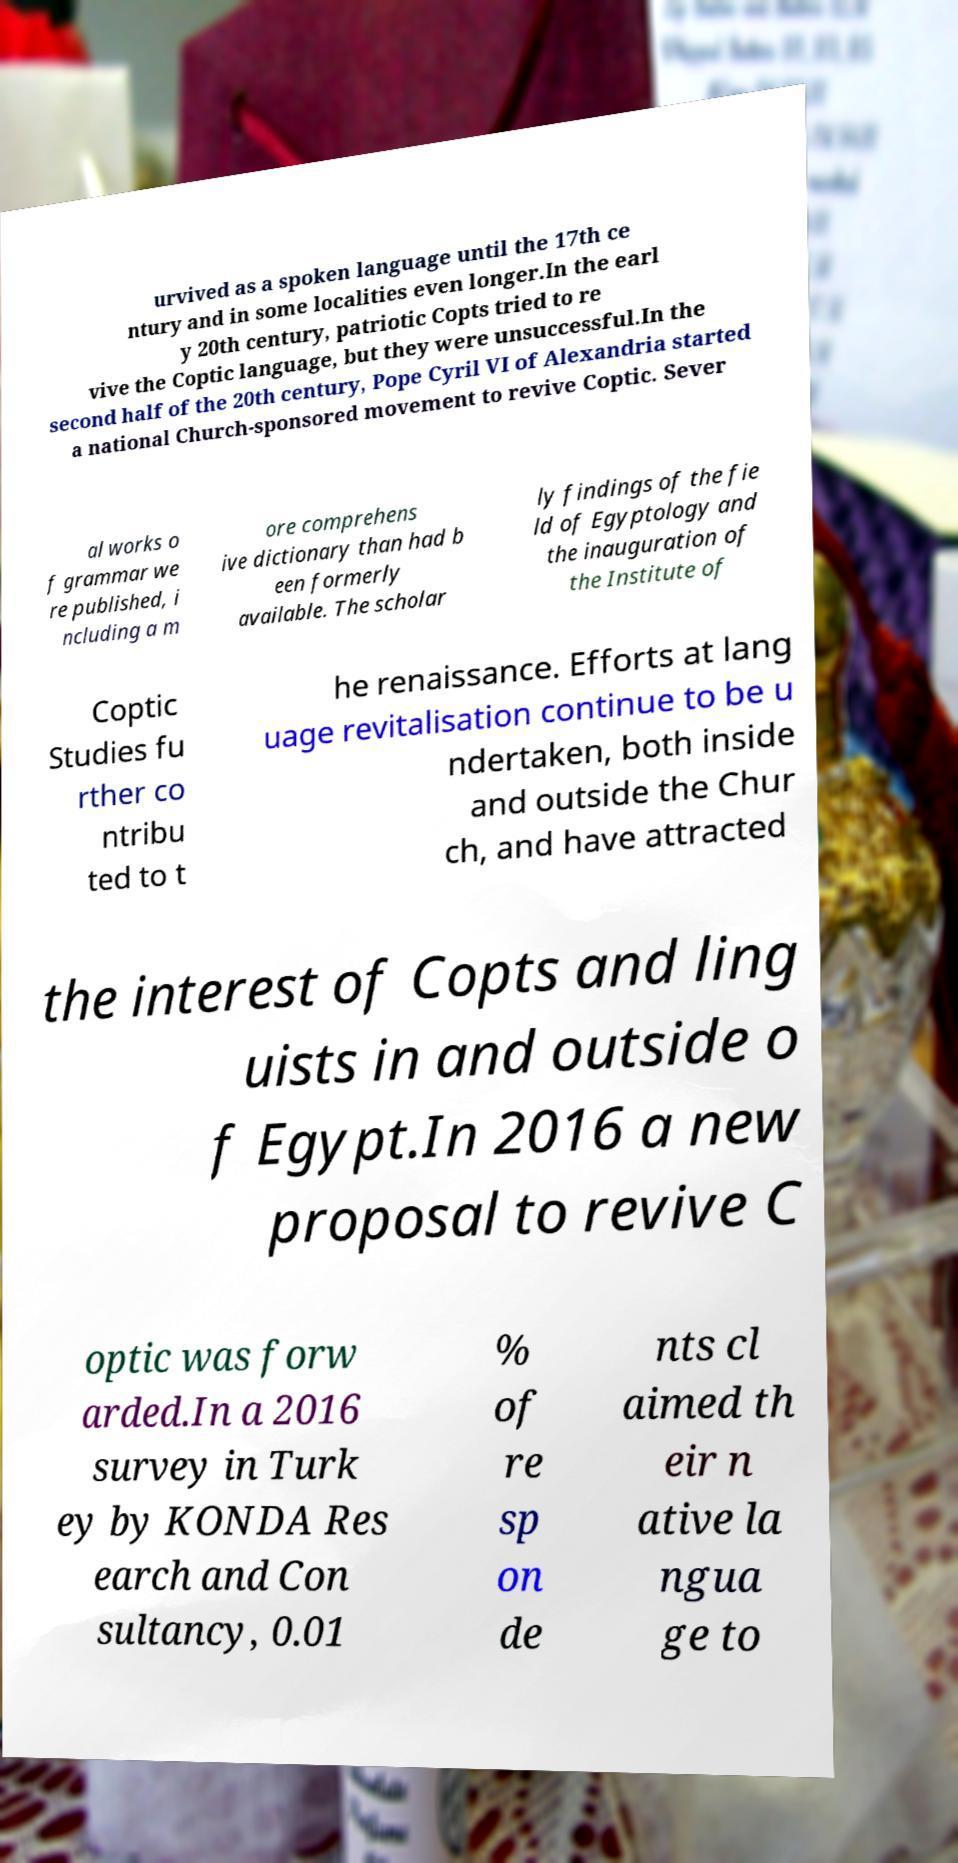Please identify and transcribe the text found in this image. urvived as a spoken language until the 17th ce ntury and in some localities even longer.In the earl y 20th century, patriotic Copts tried to re vive the Coptic language, but they were unsuccessful.In the second half of the 20th century, Pope Cyril VI of Alexandria started a national Church-sponsored movement to revive Coptic. Sever al works o f grammar we re published, i ncluding a m ore comprehens ive dictionary than had b een formerly available. The scholar ly findings of the fie ld of Egyptology and the inauguration of the Institute of Coptic Studies fu rther co ntribu ted to t he renaissance. Efforts at lang uage revitalisation continue to be u ndertaken, both inside and outside the Chur ch, and have attracted the interest of Copts and ling uists in and outside o f Egypt.In 2016 a new proposal to revive C optic was forw arded.In a 2016 survey in Turk ey by KONDA Res earch and Con sultancy, 0.01 % of re sp on de nts cl aimed th eir n ative la ngua ge to 